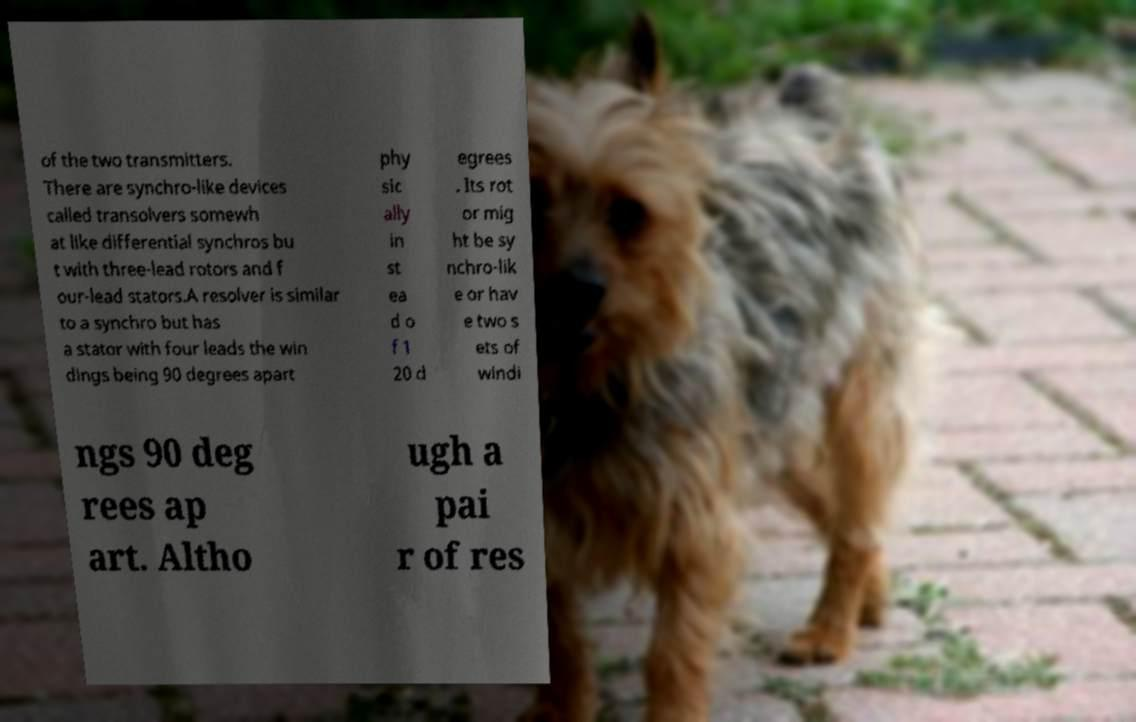There's text embedded in this image that I need extracted. Can you transcribe it verbatim? of the two transmitters. There are synchro-like devices called transolvers somewh at like differential synchros bu t with three-lead rotors and f our-lead stators.A resolver is similar to a synchro but has a stator with four leads the win dings being 90 degrees apart phy sic ally in st ea d o f 1 20 d egrees . Its rot or mig ht be sy nchro-lik e or hav e two s ets of windi ngs 90 deg rees ap art. Altho ugh a pai r of res 